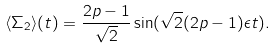<formula> <loc_0><loc_0><loc_500><loc_500>\langle \Sigma _ { 2 } \rangle ( t ) = \frac { 2 p - 1 } { \sqrt { 2 } } \sin ( \sqrt { 2 } ( 2 p - 1 ) \epsilon t ) .</formula> 